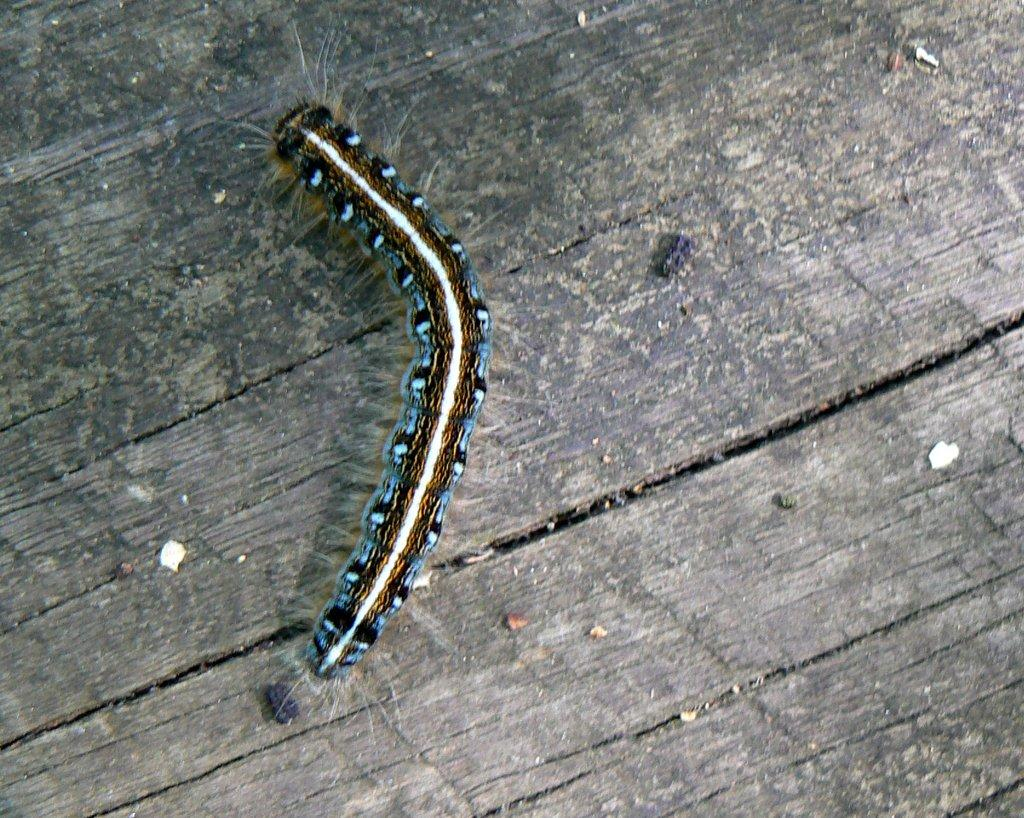What type of creature is in the image? There is a caterpillar in the image. What is the caterpillar resting on in the image? The caterpillar is on a wooden surface. What type of cord is being used to record the caterpillar's observations in the image? There is no cord or recording device present in the image, and the caterpillar is not making any observations. 